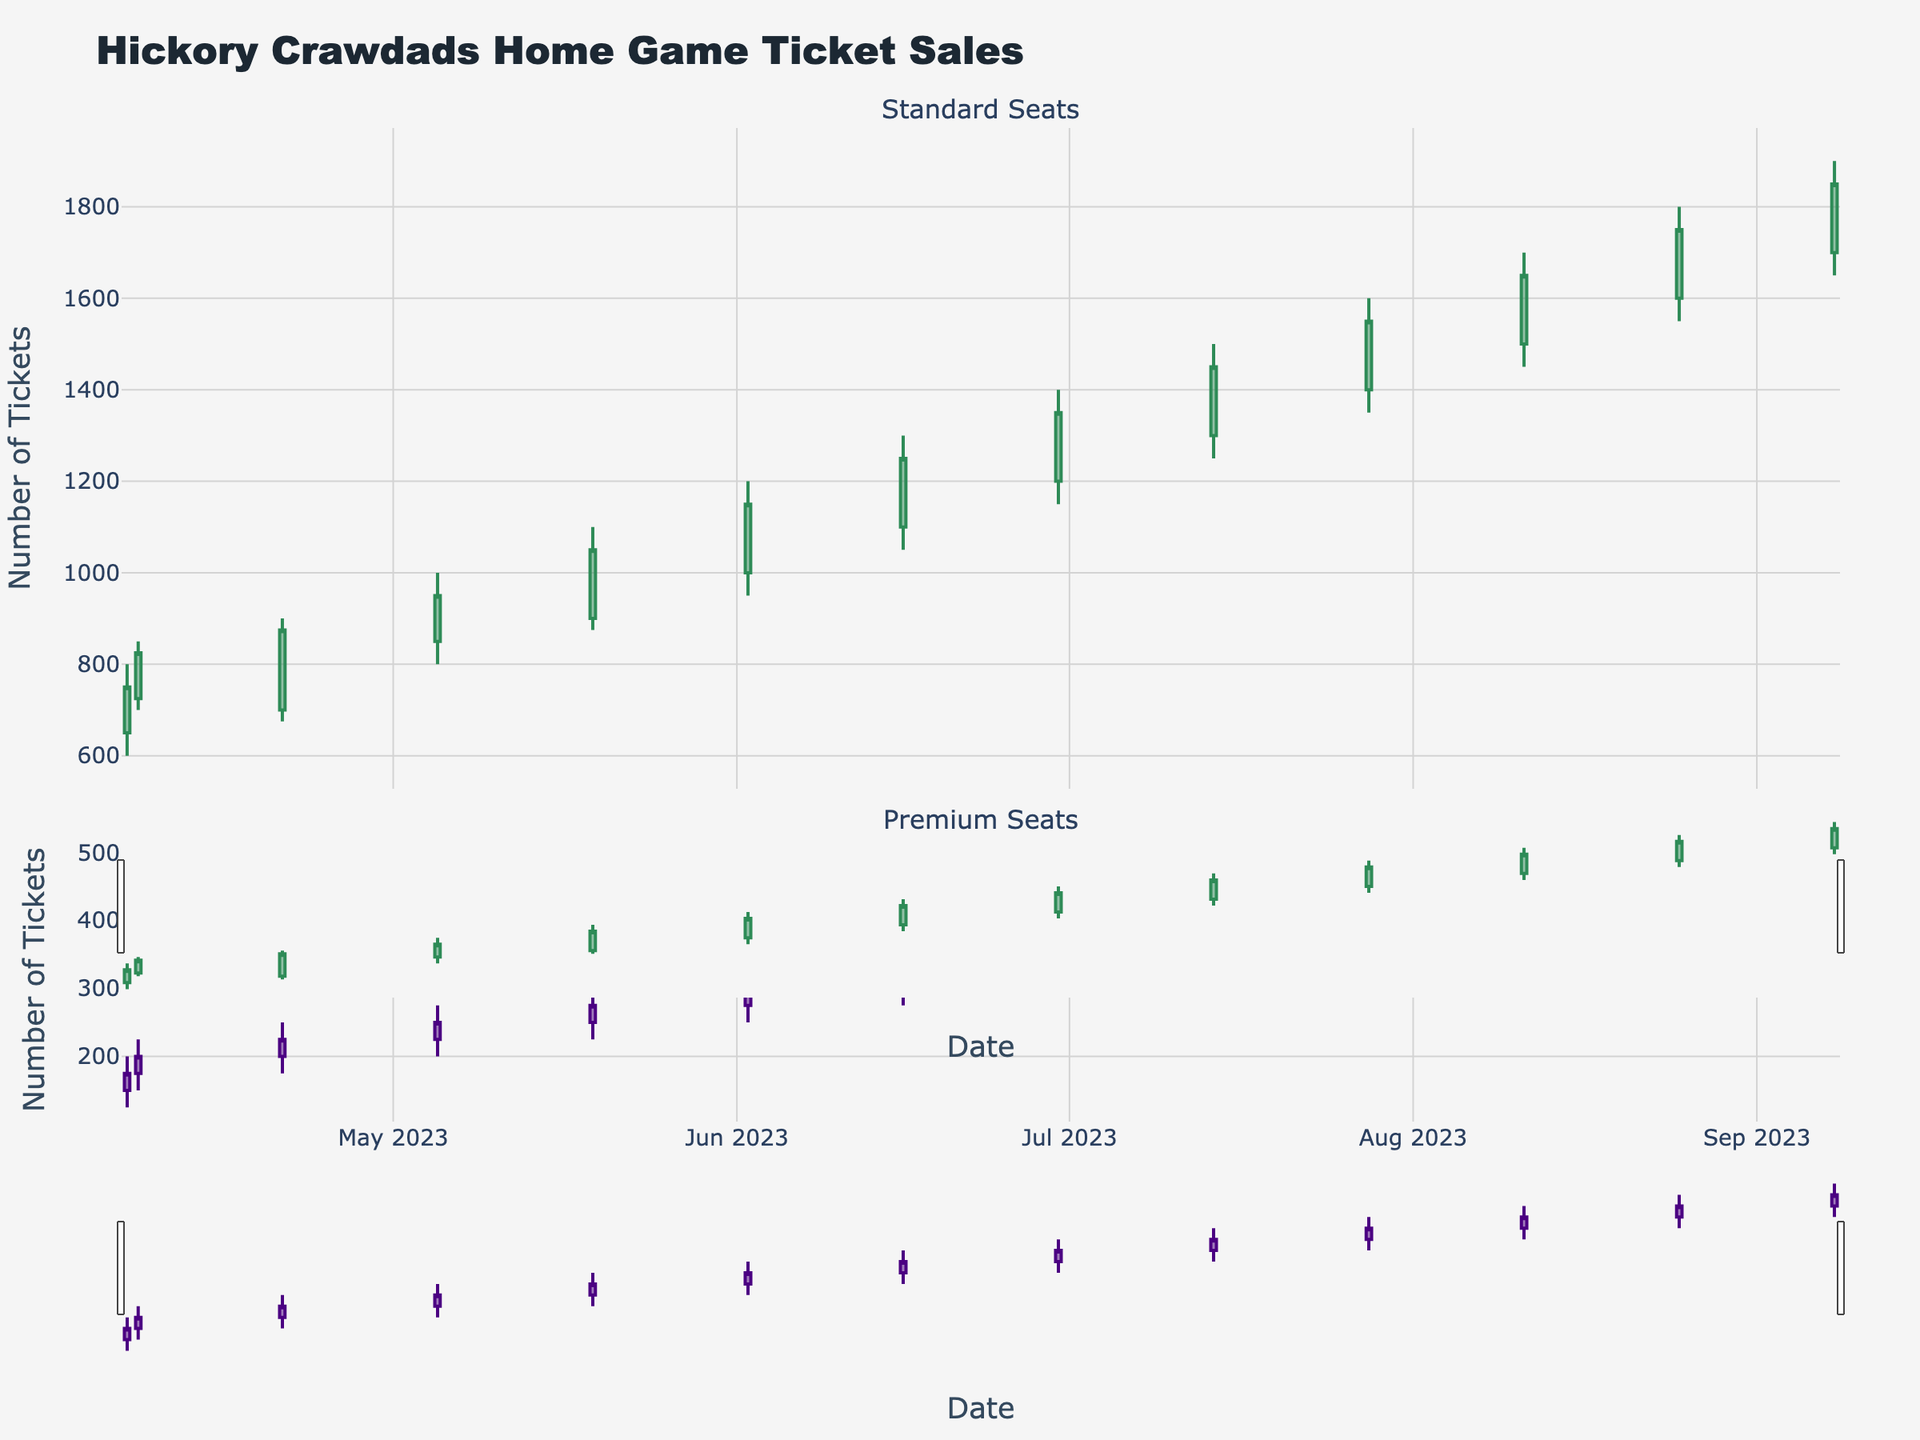What is the title of the figure? The title is located at the top of the plot and reads: "Hickory Crawdads Home Game Ticket Sales".
Answer: Hickory Crawdads Home Game Ticket Sales How many data points are plotted for each type of seat? By counting the number of candlestick plots along the x-axis for each subplot, we can see there are 13 data points plotted for both standard and premium seats.
Answer: 13 Which date has the highest closing ticket sales for standard seats? By inspecting the top part of the figure and locating the highest point on the closing line, we see that the date with the highest closing ticket sales is 2023-09-08.
Answer: 2023-09-08 Which date has the lowest opening ticket sales for premium seats? Looking at the bottom part of the figure, we find the lowest opening value is on 2023-04-07.
Answer: 2023-04-07 Did premium seat ticket sales always increase when standard seat ticket sales increased? Compare the opening and closing values of the candlestick for both subplots. For every date when standard seat sales increased (Close > Open), the same should happen for premium seats. We can see both increased on dates like 2023-04-21, 2023-05-05, etc. Yes, premium sales always increased.
Answer: Yes What was the range (high - low) of ticket sales for standard seats on 2023-07-28? On the date 2023-07-28, the high value is 1600 and the low value is 1350. The range is calculated as 1600 - 1350.
Answer: 250 What is the percentage increase in closing ticket sales for premium seats from 2023-06-02 to 2023-06-16? The closing sales for premium seats on 2023-06-02 was 300 and on 2023-06-16 was 325. The percentage increase is calculated as (325 - 300) / 300 * 100%.
Answer: 8.33% On which date did both standard and premium seats experience the smallest range of ticket sales? Calculate the high-low for each date and compare. The smallest range for both is on 2023-04-07 where the ranges are 200-150=50 for standard and 200-125=75 for premium.
Answer: 2023-04-07 Which month showed a consistent increase in closing sales for premium seats? By examining the trends in the bottom subplot for premium seats, we see that July (07) consistently shows an increase in closing sales.
Answer: July How many times did standard seat ticket sales close higher than they opened from April to September? By counting all instances where the closing value is higher than the opening value on the upper subplot, we find 11 instances (2023-04-07, 2023-04-08, 2023-04-21, 2023-05-05, 2023-05-19, 2023-06-02, 2023-06-16, 2023-06-30, 2023-07-14, 2023-08-25, 2023-09-08).
Answer: 11 